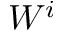Convert formula to latex. <formula><loc_0><loc_0><loc_500><loc_500>W ^ { i }</formula> 